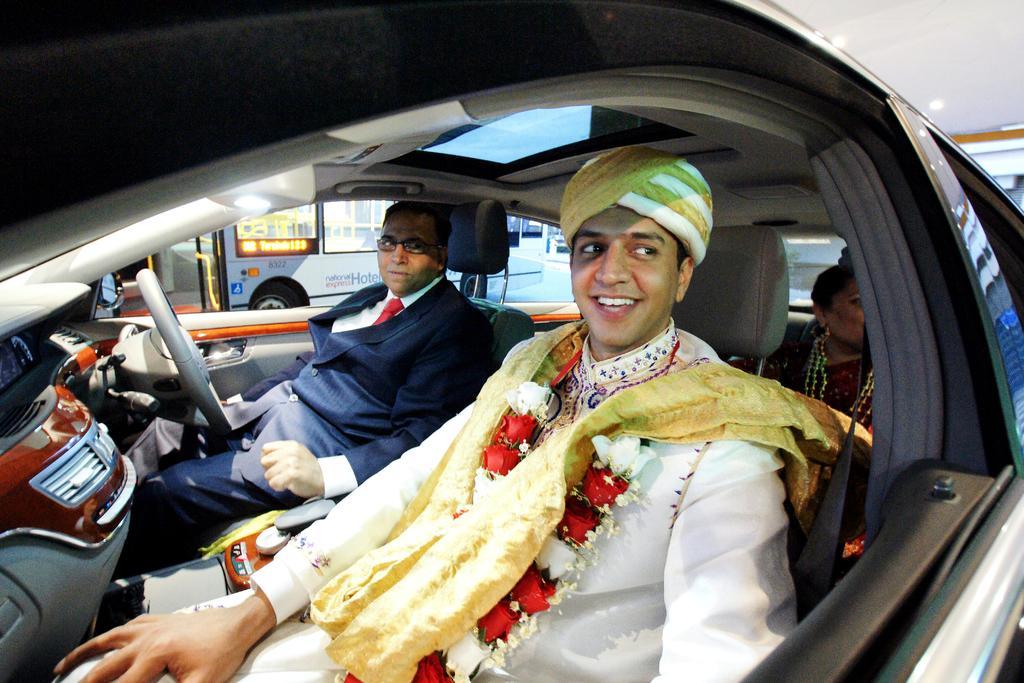In one or two sentences, can you explain what this image depicts? In the image we can see three persons were sitting in the car and they were smiling. The front person he is wearing hat. In the background there is a bus and road. 